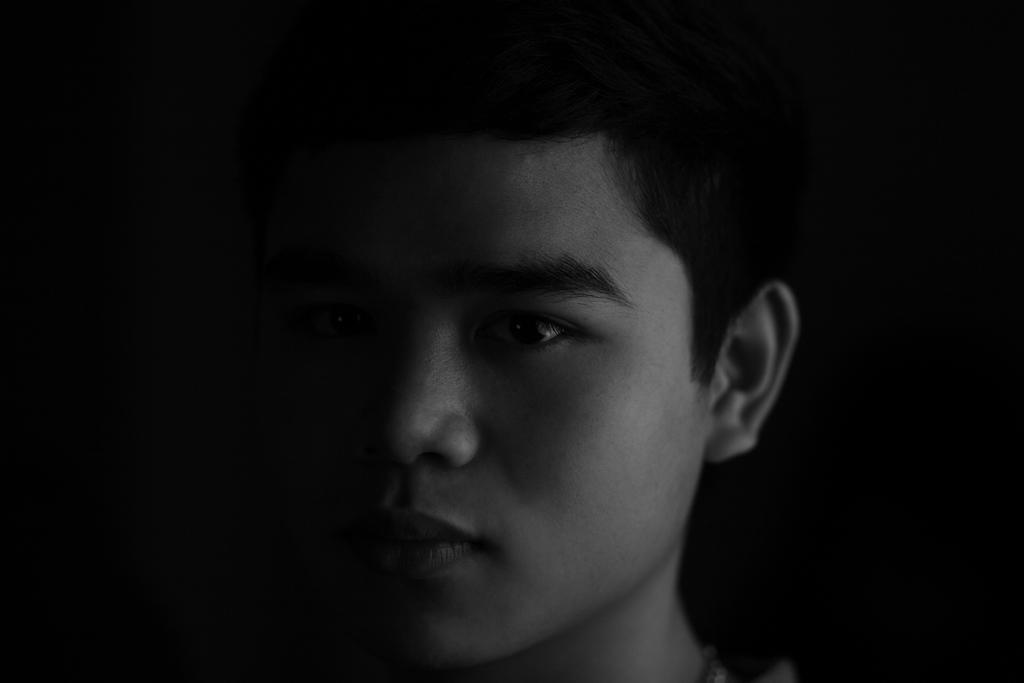Who is present in the image? There is a man in the image. What can be observed about the background of the image? The background of the image is dark. How many nails does the man have in his mouth in the image? There is no indication of nails or a mouth in the image; it only shows a man with a dark background. 